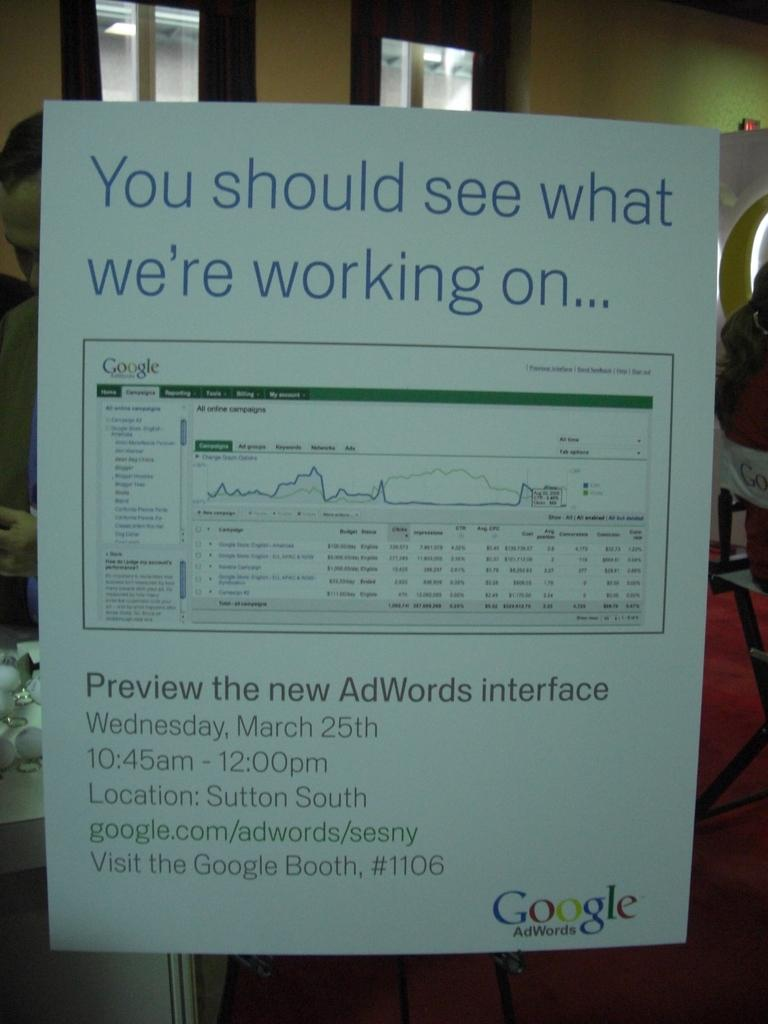<image>
Provide a brief description of the given image. Google wants you to see what they are working on. 